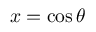Convert formula to latex. <formula><loc_0><loc_0><loc_500><loc_500>x = \cos \theta</formula> 